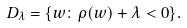<formula> <loc_0><loc_0><loc_500><loc_500>D _ { \lambda } = \{ w \colon \rho ( w ) + \lambda < 0 \} .</formula> 